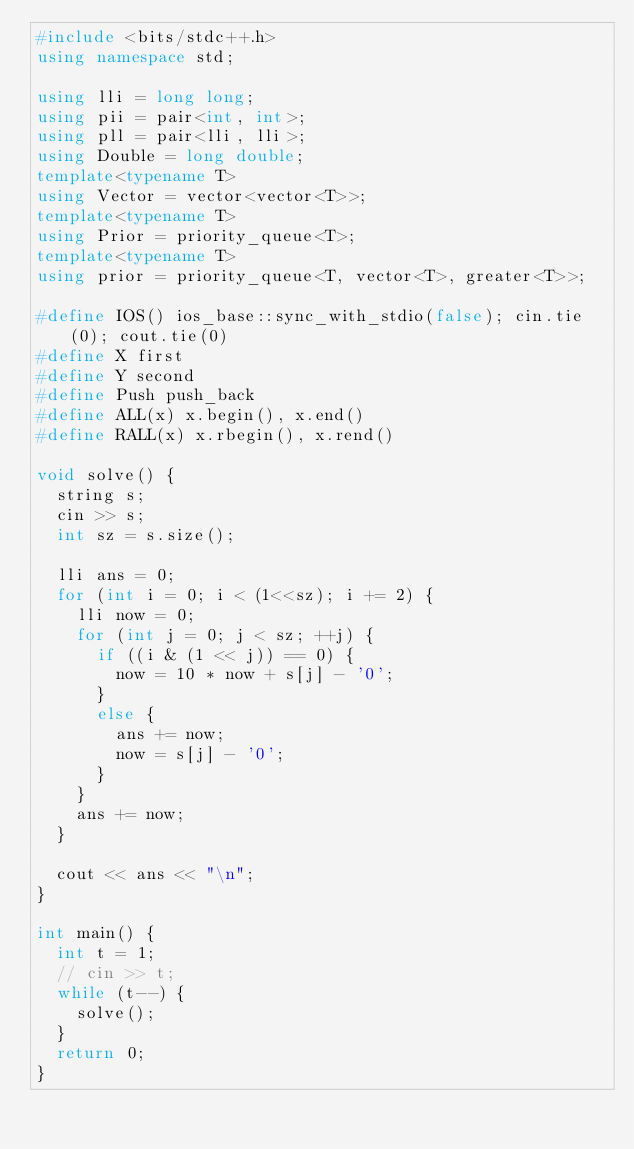<code> <loc_0><loc_0><loc_500><loc_500><_C++_>#include <bits/stdc++.h>
using namespace std;

using lli = long long;
using pii = pair<int, int>;
using pll = pair<lli, lli>;
using Double = long double;
template<typename T>
using Vector = vector<vector<T>>;
template<typename T>
using Prior = priority_queue<T>;
template<typename T>
using prior = priority_queue<T, vector<T>, greater<T>>;

#define IOS() ios_base::sync_with_stdio(false); cin.tie(0); cout.tie(0)
#define X first
#define Y second
#define Push push_back
#define ALL(x) x.begin(), x.end()
#define RALL(x) x.rbegin(), x.rend()

void solve() {
	string s;
	cin >> s;
	int sz = s.size();

	lli ans = 0;
	for (int i = 0; i < (1<<sz); i += 2) {
		lli now = 0;
		for (int j = 0; j < sz; ++j) {
			if ((i & (1 << j)) == 0) {
				now = 10 * now + s[j] - '0';
			}
			else {
				ans += now;
				now = s[j] - '0';
			}
		}
		ans += now;
	}

	cout << ans << "\n";
}

int main() {
	int t = 1;
	// cin >> t;
	while (t--) {
		solve();
	}
	return 0;
}</code> 